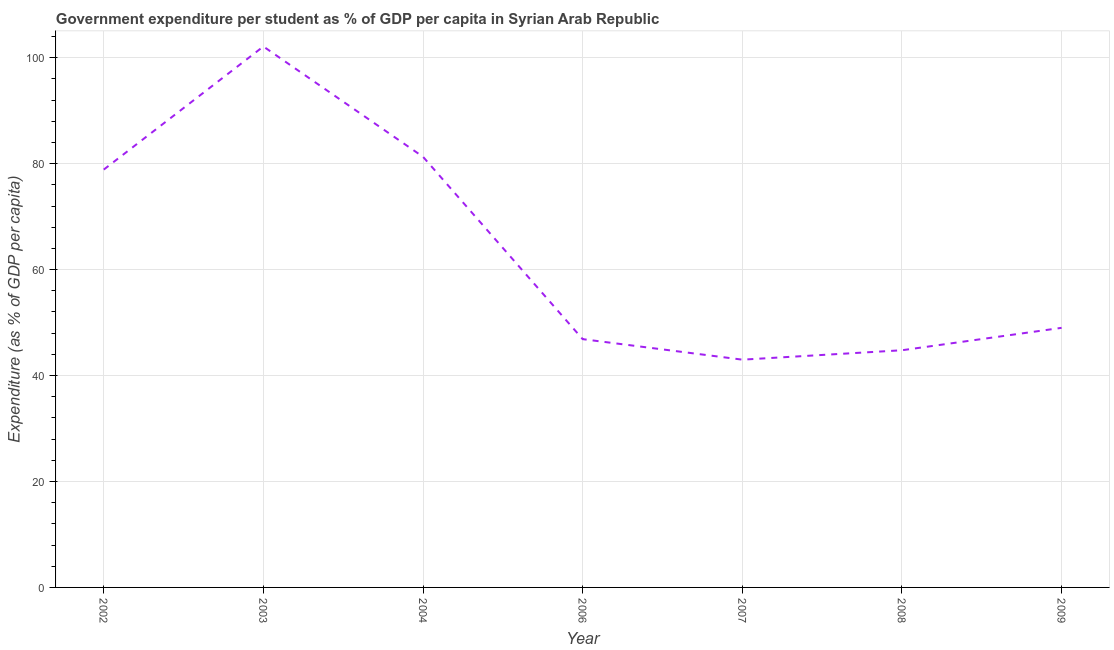What is the government expenditure per student in 2004?
Give a very brief answer. 81.29. Across all years, what is the maximum government expenditure per student?
Offer a terse response. 102.11. Across all years, what is the minimum government expenditure per student?
Give a very brief answer. 42.99. In which year was the government expenditure per student maximum?
Offer a terse response. 2003. What is the sum of the government expenditure per student?
Your answer should be very brief. 445.91. What is the difference between the government expenditure per student in 2004 and 2007?
Ensure brevity in your answer.  38.29. What is the average government expenditure per student per year?
Give a very brief answer. 63.7. What is the median government expenditure per student?
Your answer should be compact. 49. In how many years, is the government expenditure per student greater than 92 %?
Provide a succinct answer. 1. Do a majority of the years between 2009 and 2008 (inclusive) have government expenditure per student greater than 4 %?
Give a very brief answer. No. What is the ratio of the government expenditure per student in 2008 to that in 2009?
Keep it short and to the point. 0.91. Is the difference between the government expenditure per student in 2007 and 2009 greater than the difference between any two years?
Keep it short and to the point. No. What is the difference between the highest and the second highest government expenditure per student?
Offer a very short reply. 20.83. Is the sum of the government expenditure per student in 2003 and 2004 greater than the maximum government expenditure per student across all years?
Make the answer very short. Yes. What is the difference between the highest and the lowest government expenditure per student?
Offer a very short reply. 59.12. In how many years, is the government expenditure per student greater than the average government expenditure per student taken over all years?
Provide a succinct answer. 3. Does the government expenditure per student monotonically increase over the years?
Make the answer very short. No. How many years are there in the graph?
Ensure brevity in your answer.  7. What is the difference between two consecutive major ticks on the Y-axis?
Your answer should be very brief. 20. Does the graph contain any zero values?
Offer a very short reply. No. What is the title of the graph?
Provide a short and direct response. Government expenditure per student as % of GDP per capita in Syrian Arab Republic. What is the label or title of the X-axis?
Your answer should be compact. Year. What is the label or title of the Y-axis?
Provide a succinct answer. Expenditure (as % of GDP per capita). What is the Expenditure (as % of GDP per capita) in 2002?
Give a very brief answer. 78.87. What is the Expenditure (as % of GDP per capita) in 2003?
Provide a short and direct response. 102.11. What is the Expenditure (as % of GDP per capita) in 2004?
Provide a succinct answer. 81.29. What is the Expenditure (as % of GDP per capita) of 2006?
Give a very brief answer. 46.87. What is the Expenditure (as % of GDP per capita) of 2007?
Ensure brevity in your answer.  42.99. What is the Expenditure (as % of GDP per capita) of 2008?
Provide a succinct answer. 44.77. What is the Expenditure (as % of GDP per capita) in 2009?
Provide a succinct answer. 49. What is the difference between the Expenditure (as % of GDP per capita) in 2002 and 2003?
Offer a very short reply. -23.24. What is the difference between the Expenditure (as % of GDP per capita) in 2002 and 2004?
Your answer should be compact. -2.41. What is the difference between the Expenditure (as % of GDP per capita) in 2002 and 2006?
Your answer should be compact. 32. What is the difference between the Expenditure (as % of GDP per capita) in 2002 and 2007?
Ensure brevity in your answer.  35.88. What is the difference between the Expenditure (as % of GDP per capita) in 2002 and 2008?
Your response must be concise. 34.1. What is the difference between the Expenditure (as % of GDP per capita) in 2002 and 2009?
Make the answer very short. 29.87. What is the difference between the Expenditure (as % of GDP per capita) in 2003 and 2004?
Your answer should be compact. 20.83. What is the difference between the Expenditure (as % of GDP per capita) in 2003 and 2006?
Give a very brief answer. 55.24. What is the difference between the Expenditure (as % of GDP per capita) in 2003 and 2007?
Give a very brief answer. 59.12. What is the difference between the Expenditure (as % of GDP per capita) in 2003 and 2008?
Offer a very short reply. 57.34. What is the difference between the Expenditure (as % of GDP per capita) in 2003 and 2009?
Make the answer very short. 53.11. What is the difference between the Expenditure (as % of GDP per capita) in 2004 and 2006?
Give a very brief answer. 34.42. What is the difference between the Expenditure (as % of GDP per capita) in 2004 and 2007?
Offer a very short reply. 38.29. What is the difference between the Expenditure (as % of GDP per capita) in 2004 and 2008?
Give a very brief answer. 36.52. What is the difference between the Expenditure (as % of GDP per capita) in 2004 and 2009?
Give a very brief answer. 32.28. What is the difference between the Expenditure (as % of GDP per capita) in 2006 and 2007?
Your response must be concise. 3.88. What is the difference between the Expenditure (as % of GDP per capita) in 2006 and 2008?
Make the answer very short. 2.1. What is the difference between the Expenditure (as % of GDP per capita) in 2006 and 2009?
Give a very brief answer. -2.13. What is the difference between the Expenditure (as % of GDP per capita) in 2007 and 2008?
Keep it short and to the point. -1.78. What is the difference between the Expenditure (as % of GDP per capita) in 2007 and 2009?
Provide a succinct answer. -6.01. What is the difference between the Expenditure (as % of GDP per capita) in 2008 and 2009?
Give a very brief answer. -4.23. What is the ratio of the Expenditure (as % of GDP per capita) in 2002 to that in 2003?
Offer a very short reply. 0.77. What is the ratio of the Expenditure (as % of GDP per capita) in 2002 to that in 2006?
Provide a succinct answer. 1.68. What is the ratio of the Expenditure (as % of GDP per capita) in 2002 to that in 2007?
Ensure brevity in your answer.  1.83. What is the ratio of the Expenditure (as % of GDP per capita) in 2002 to that in 2008?
Your answer should be compact. 1.76. What is the ratio of the Expenditure (as % of GDP per capita) in 2002 to that in 2009?
Make the answer very short. 1.61. What is the ratio of the Expenditure (as % of GDP per capita) in 2003 to that in 2004?
Offer a very short reply. 1.26. What is the ratio of the Expenditure (as % of GDP per capita) in 2003 to that in 2006?
Make the answer very short. 2.18. What is the ratio of the Expenditure (as % of GDP per capita) in 2003 to that in 2007?
Your answer should be compact. 2.38. What is the ratio of the Expenditure (as % of GDP per capita) in 2003 to that in 2008?
Your response must be concise. 2.28. What is the ratio of the Expenditure (as % of GDP per capita) in 2003 to that in 2009?
Offer a terse response. 2.08. What is the ratio of the Expenditure (as % of GDP per capita) in 2004 to that in 2006?
Your response must be concise. 1.73. What is the ratio of the Expenditure (as % of GDP per capita) in 2004 to that in 2007?
Make the answer very short. 1.89. What is the ratio of the Expenditure (as % of GDP per capita) in 2004 to that in 2008?
Ensure brevity in your answer.  1.82. What is the ratio of the Expenditure (as % of GDP per capita) in 2004 to that in 2009?
Provide a succinct answer. 1.66. What is the ratio of the Expenditure (as % of GDP per capita) in 2006 to that in 2007?
Your answer should be compact. 1.09. What is the ratio of the Expenditure (as % of GDP per capita) in 2006 to that in 2008?
Your response must be concise. 1.05. What is the ratio of the Expenditure (as % of GDP per capita) in 2006 to that in 2009?
Your answer should be very brief. 0.96. What is the ratio of the Expenditure (as % of GDP per capita) in 2007 to that in 2009?
Offer a terse response. 0.88. What is the ratio of the Expenditure (as % of GDP per capita) in 2008 to that in 2009?
Give a very brief answer. 0.91. 